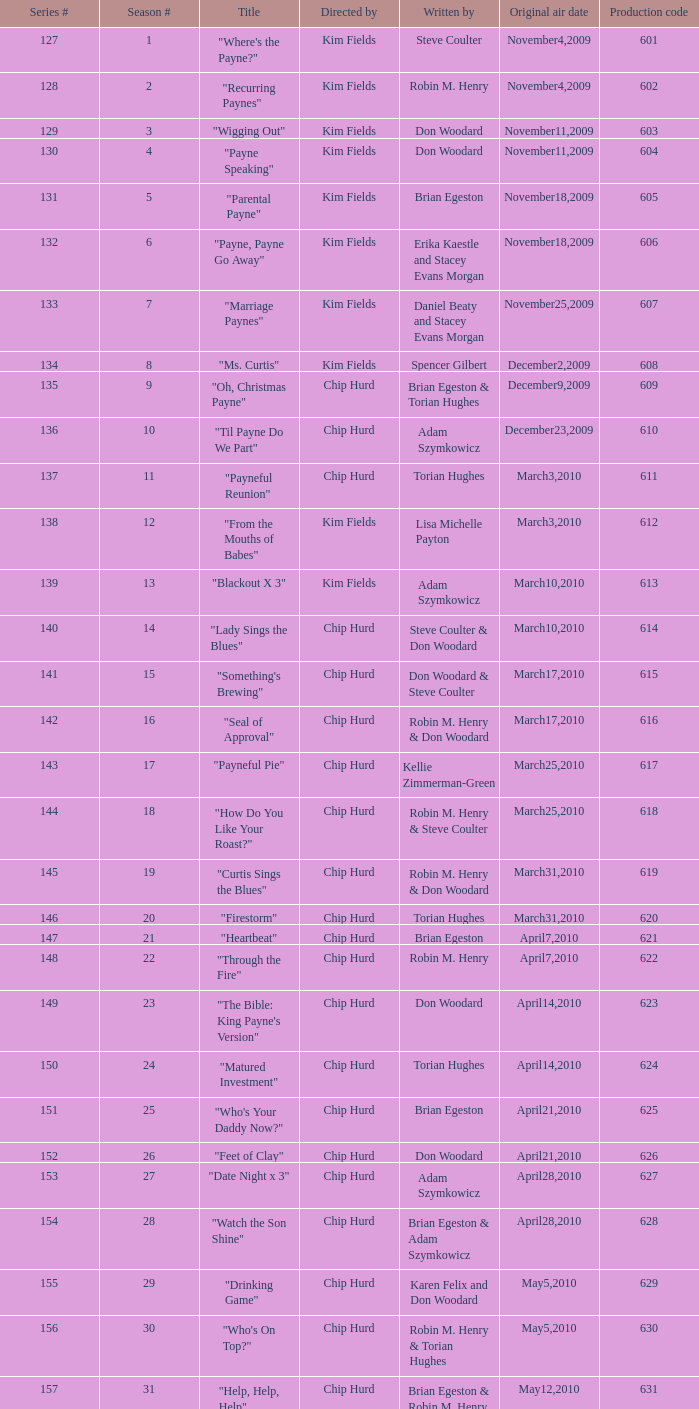When were the initial air dates for the title "firestorm"? March31,2010. 